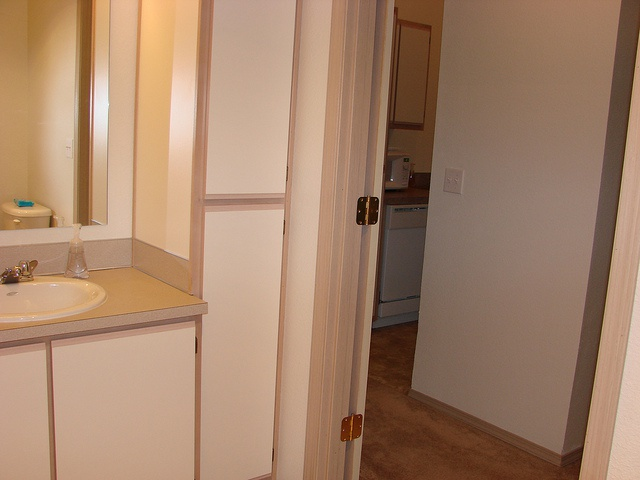Describe the objects in this image and their specific colors. I can see sink in olive, tan, and gray tones, microwave in olive, maroon, black, and gray tones, and bottle in olive, gray, and tan tones in this image. 